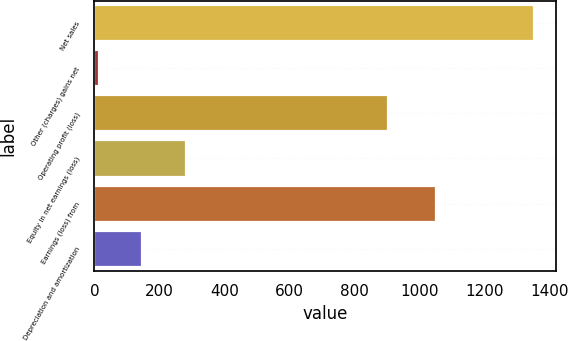Convert chart. <chart><loc_0><loc_0><loc_500><loc_500><bar_chart><fcel>Net sales<fcel>Other (charges) gains net<fcel>Operating profit (loss)<fcel>Equity in net earnings (loss)<fcel>Earnings (loss) from<fcel>Depreciation and amortization<nl><fcel>1352<fcel>13<fcel>904<fcel>280.8<fcel>1053<fcel>146.9<nl></chart> 